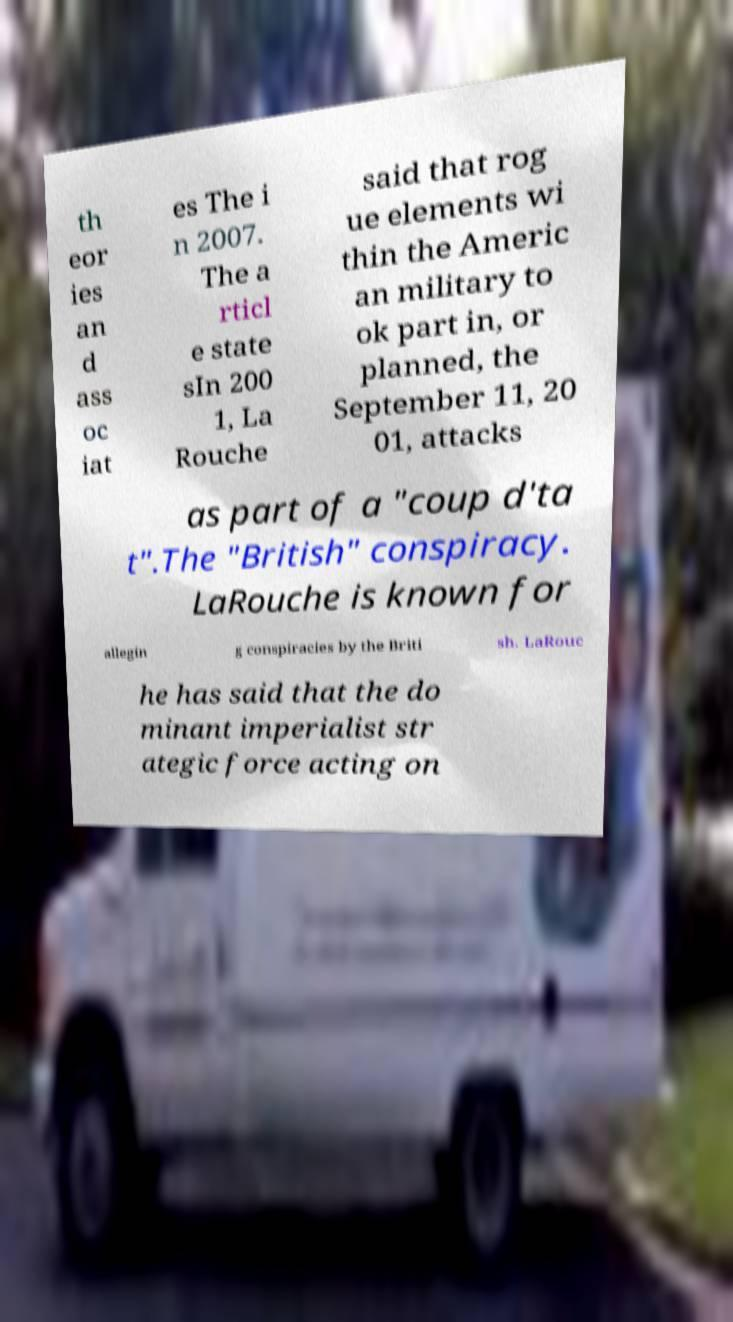Can you read and provide the text displayed in the image?This photo seems to have some interesting text. Can you extract and type it out for me? th eor ies an d ass oc iat es The i n 2007. The a rticl e state sIn 200 1, La Rouche said that rog ue elements wi thin the Americ an military to ok part in, or planned, the September 11, 20 01, attacks as part of a "coup d'ta t".The "British" conspiracy. LaRouche is known for allegin g conspiracies by the Briti sh. LaRouc he has said that the do minant imperialist str ategic force acting on 